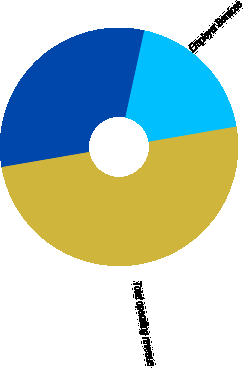<chart> <loc_0><loc_0><loc_500><loc_500><pie_chart><fcel>Verification Services<fcel>Employer Services<fcel>Total operating revenue<nl><fcel>31.14%<fcel>18.86%<fcel>50.0%<nl></chart> 